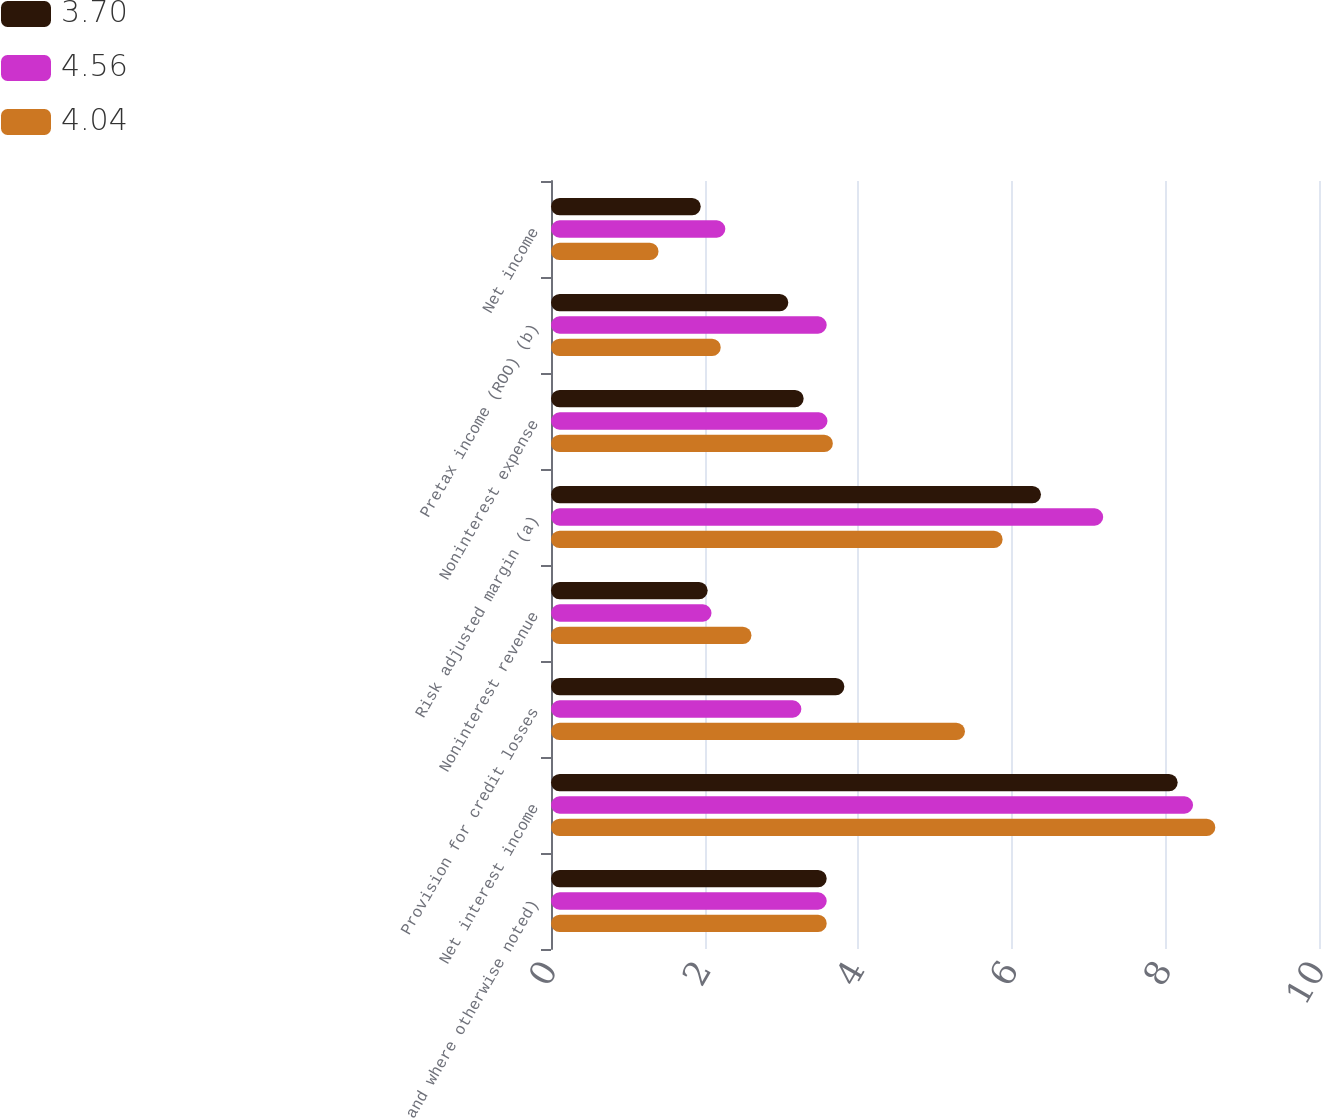<chart> <loc_0><loc_0><loc_500><loc_500><stacked_bar_chart><ecel><fcel>and where otherwise noted)<fcel>Net interest income<fcel>Provision for credit losses<fcel>Noninterest revenue<fcel>Risk adjusted margin (a)<fcel>Noninterest expense<fcel>Pretax income (ROO) (b)<fcel>Net income<nl><fcel>3.7<fcel>3.59<fcel>8.16<fcel>3.82<fcel>2.04<fcel>6.38<fcel>3.29<fcel>3.09<fcel>1.95<nl><fcel>4.56<fcel>3.59<fcel>8.36<fcel>3.26<fcel>2.09<fcel>7.19<fcel>3.6<fcel>3.59<fcel>2.27<nl><fcel>4.04<fcel>3.59<fcel>8.65<fcel>5.39<fcel>2.61<fcel>5.88<fcel>3.67<fcel>2.21<fcel>1.4<nl></chart> 